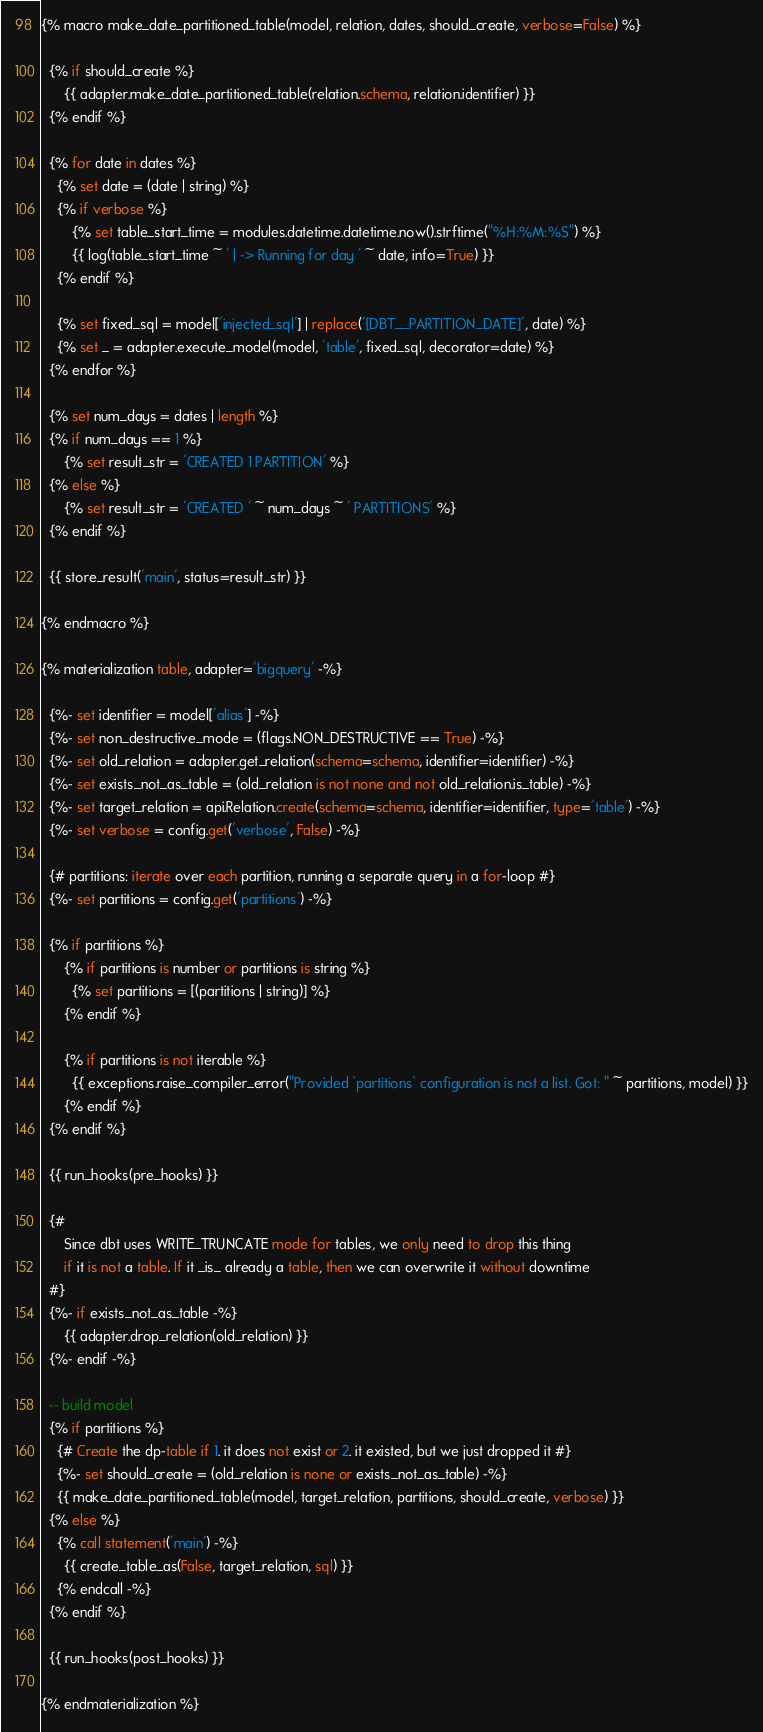<code> <loc_0><loc_0><loc_500><loc_500><_SQL_>{% macro make_date_partitioned_table(model, relation, dates, should_create, verbose=False) %}

  {% if should_create %}
      {{ adapter.make_date_partitioned_table(relation.schema, relation.identifier) }}
  {% endif %}

  {% for date in dates %}
    {% set date = (date | string) %}
    {% if verbose %}
        {% set table_start_time = modules.datetime.datetime.now().strftime("%H:%M:%S") %}
        {{ log(table_start_time ~ ' | -> Running for day ' ~ date, info=True) }}
    {% endif %}

    {% set fixed_sql = model['injected_sql'] | replace('[DBT__PARTITION_DATE]', date) %}
    {% set _ = adapter.execute_model(model, 'table', fixed_sql, decorator=date) %}
  {% endfor %}

  {% set num_days = dates | length %}
  {% if num_days == 1 %}
      {% set result_str = 'CREATED 1 PARTITION' %}
  {% else %}
      {% set result_str = 'CREATED ' ~ num_days ~ ' PARTITIONS' %}
  {% endif %}

  {{ store_result('main', status=result_str) }}

{% endmacro %}

{% materialization table, adapter='bigquery' -%}

  {%- set identifier = model['alias'] -%}
  {%- set non_destructive_mode = (flags.NON_DESTRUCTIVE == True) -%}
  {%- set old_relation = adapter.get_relation(schema=schema, identifier=identifier) -%}
  {%- set exists_not_as_table = (old_relation is not none and not old_relation.is_table) -%}
  {%- set target_relation = api.Relation.create(schema=schema, identifier=identifier, type='table') -%}
  {%- set verbose = config.get('verbose', False) -%}

  {# partitions: iterate over each partition, running a separate query in a for-loop #}
  {%- set partitions = config.get('partitions') -%}

  {% if partitions %}
      {% if partitions is number or partitions is string %}
        {% set partitions = [(partitions | string)] %}
      {% endif %}

      {% if partitions is not iterable %}
        {{ exceptions.raise_compiler_error("Provided `partitions` configuration is not a list. Got: " ~ partitions, model) }}
      {% endif %}
  {% endif %}

  {{ run_hooks(pre_hooks) }}

  {#
      Since dbt uses WRITE_TRUNCATE mode for tables, we only need to drop this thing
      if it is not a table. If it _is_ already a table, then we can overwrite it without downtime
  #}
  {%- if exists_not_as_table -%}
      {{ adapter.drop_relation(old_relation) }}
  {%- endif -%}

  -- build model
  {% if partitions %}
    {# Create the dp-table if 1. it does not exist or 2. it existed, but we just dropped it #}
    {%- set should_create = (old_relation is none or exists_not_as_table) -%}
    {{ make_date_partitioned_table(model, target_relation, partitions, should_create, verbose) }}
  {% else %}
    {% call statement('main') -%}
      {{ create_table_as(False, target_relation, sql) }}
    {% endcall -%}
  {% endif %}

  {{ run_hooks(post_hooks) }}

{% endmaterialization %}
</code> 